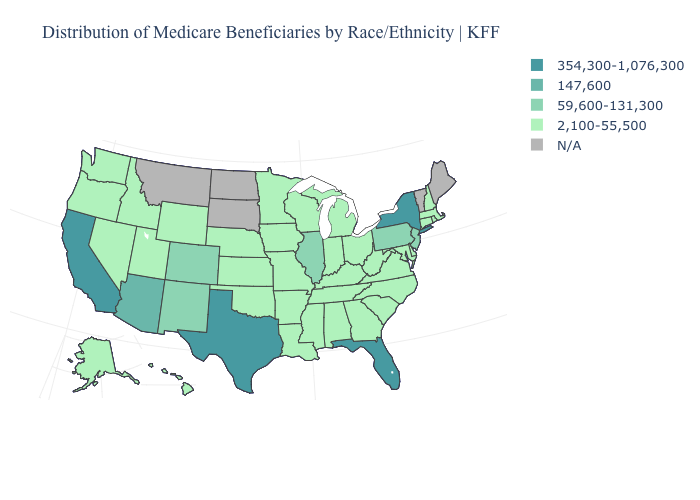Does the first symbol in the legend represent the smallest category?
Answer briefly. No. What is the value of Arizona?
Be succinct. 147,600. Name the states that have a value in the range N/A?
Keep it brief. Maine, Montana, North Dakota, South Dakota, Vermont. Among the states that border Missouri , does Kansas have the lowest value?
Short answer required. Yes. Name the states that have a value in the range 354,300-1,076,300?
Keep it brief. California, Florida, New York, Texas. Does Illinois have the lowest value in the USA?
Give a very brief answer. No. Does Idaho have the lowest value in the USA?
Write a very short answer. Yes. Is the legend a continuous bar?
Keep it brief. No. Does Illinois have the highest value in the MidWest?
Be succinct. Yes. Name the states that have a value in the range 354,300-1,076,300?
Answer briefly. California, Florida, New York, Texas. Does Michigan have the lowest value in the MidWest?
Keep it brief. Yes. What is the value of Oregon?
Write a very short answer. 2,100-55,500. Name the states that have a value in the range 147,600?
Answer briefly. Arizona. Among the states that border Wisconsin , does Iowa have the highest value?
Be succinct. No. 